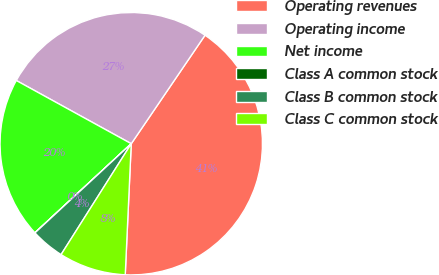<chart> <loc_0><loc_0><loc_500><loc_500><pie_chart><fcel>Operating revenues<fcel>Operating income<fcel>Net income<fcel>Class A common stock<fcel>Class B common stock<fcel>Class C common stock<nl><fcel>41.22%<fcel>26.5%<fcel>19.88%<fcel>0.01%<fcel>4.13%<fcel>8.25%<nl></chart> 